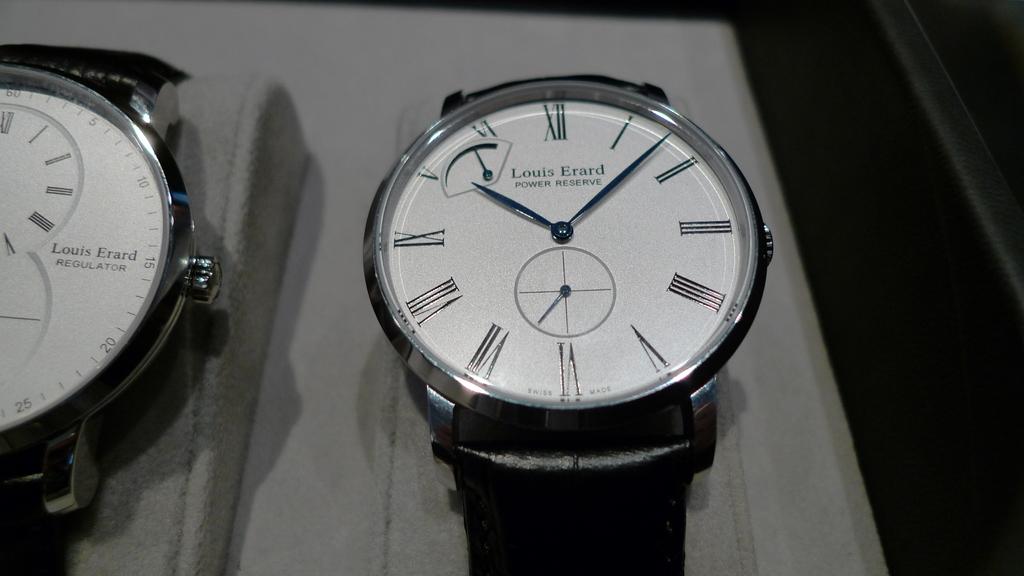What's the name on the watch?
Your response must be concise. Louis erard. What time is it?
Provide a succinct answer. 10:08. 